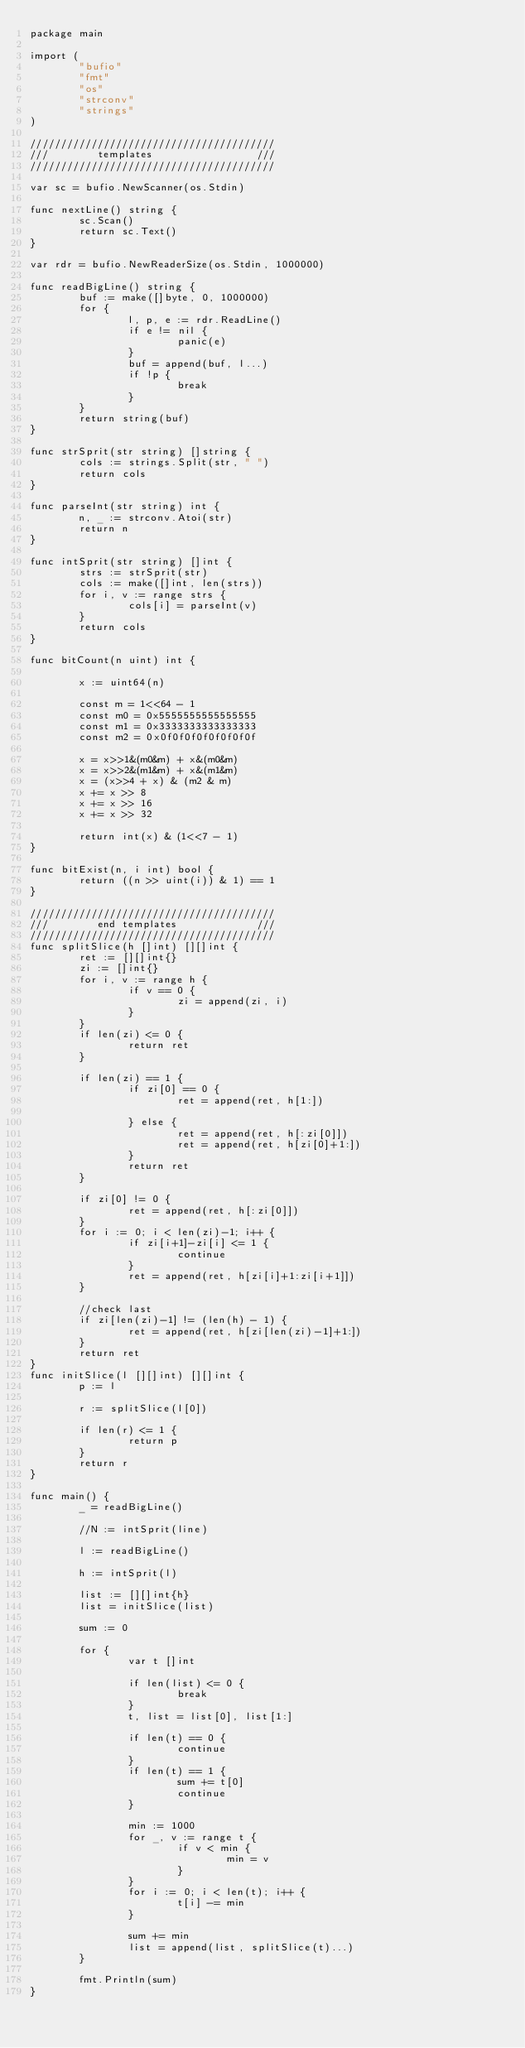<code> <loc_0><loc_0><loc_500><loc_500><_Go_>package main

import (
        "bufio"
        "fmt"
        "os"
        "strconv"
        "strings"
)

////////////////////////////////////////
///        templates                 ///
////////////////////////////////////////

var sc = bufio.NewScanner(os.Stdin)

func nextLine() string {
        sc.Scan()
        return sc.Text()
}

var rdr = bufio.NewReaderSize(os.Stdin, 1000000)

func readBigLine() string {
        buf := make([]byte, 0, 1000000)
        for {
                l, p, e := rdr.ReadLine()
                if e != nil {
                        panic(e)
                }
                buf = append(buf, l...)
                if !p {
                        break
                }
        }
        return string(buf)
}

func strSprit(str string) []string {
        cols := strings.Split(str, " ")
        return cols
}

func parseInt(str string) int {
        n, _ := strconv.Atoi(str)
        return n
}

func intSprit(str string) []int {
        strs := strSprit(str)
        cols := make([]int, len(strs))
        for i, v := range strs {
                cols[i] = parseInt(v)
        }
        return cols
}

func bitCount(n uint) int {

        x := uint64(n)

        const m = 1<<64 - 1
        const m0 = 0x5555555555555555
        const m1 = 0x3333333333333333
        const m2 = 0x0f0f0f0f0f0f0f0f

        x = x>>1&(m0&m) + x&(m0&m)
        x = x>>2&(m1&m) + x&(m1&m)
        x = (x>>4 + x) & (m2 & m)
        x += x >> 8
        x += x >> 16
        x += x >> 32

        return int(x) & (1<<7 - 1)
}

func bitExist(n, i int) bool {
        return ((n >> uint(i)) & 1) == 1
}

////////////////////////////////////////
///        end templates             ///
////////////////////////////////////////
func splitSlice(h []int) [][]int {
        ret := [][]int{}
        zi := []int{}
        for i, v := range h {
                if v == 0 {
                        zi = append(zi, i)
                }
        }
        if len(zi) <= 0 {
                return ret
        }

        if len(zi) == 1 {
                if zi[0] == 0 {
                        ret = append(ret, h[1:])

                } else {
                        ret = append(ret, h[:zi[0]])
                        ret = append(ret, h[zi[0]+1:])
                }
                return ret
        }

        if zi[0] != 0 {
                ret = append(ret, h[:zi[0]])
        }
        for i := 0; i < len(zi)-1; i++ {
                if zi[i+1]-zi[i] <= 1 {
                        continue
                }
                ret = append(ret, h[zi[i]+1:zi[i+1]])
        }

        //check last
        if zi[len(zi)-1] != (len(h) - 1) {
                ret = append(ret, h[zi[len(zi)-1]+1:])
        }
        return ret
}
func initSlice(l [][]int) [][]int {
        p := l

        r := splitSlice(l[0])

        if len(r) <= 1 {
                return p
        }
        return r
}

func main() {
        _ = readBigLine()

        //N := intSprit(line)

        l := readBigLine()

        h := intSprit(l)

        list := [][]int{h}
        list = initSlice(list)

        sum := 0

        for {
                var t []int

                if len(list) <= 0 {
                        break
                }
                t, list = list[0], list[1:]

                if len(t) == 0 {
                        continue
                }
                if len(t) == 1 {
                        sum += t[0]
                        continue
                }

                min := 1000
                for _, v := range t {
                        if v < min {
                                min = v
                        }
                }
                for i := 0; i < len(t); i++ {
                        t[i] -= min
                }

                sum += min
                list = append(list, splitSlice(t)...)
        }

        fmt.Println(sum)
}</code> 